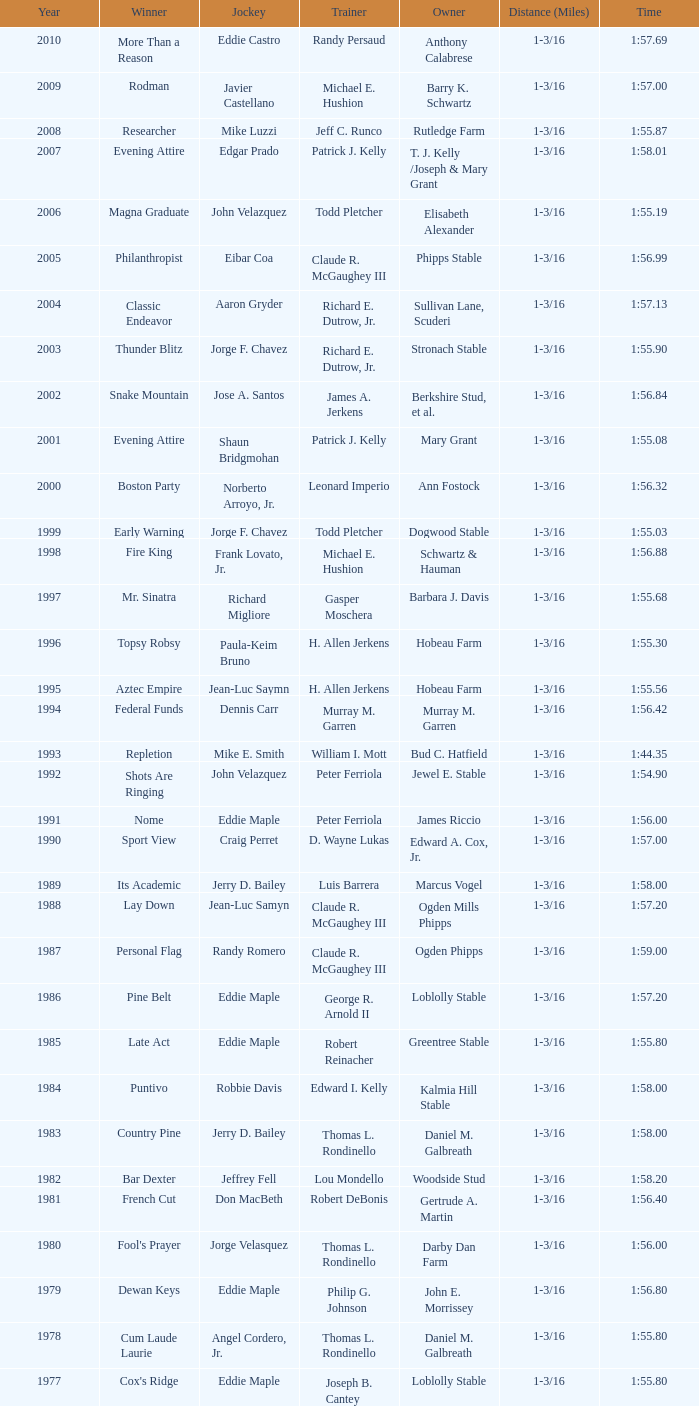What was the successful time for the winning horse, kentucky ii? 1:38.80. 